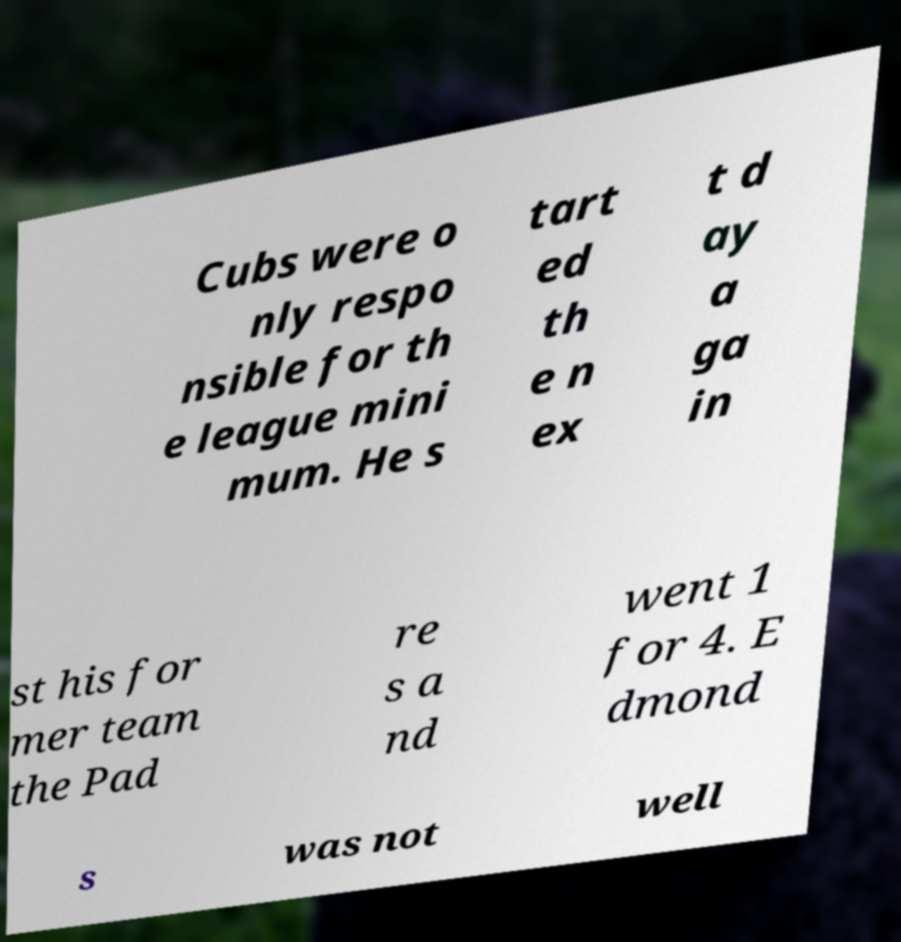Could you extract and type out the text from this image? Cubs were o nly respo nsible for th e league mini mum. He s tart ed th e n ex t d ay a ga in st his for mer team the Pad re s a nd went 1 for 4. E dmond s was not well 